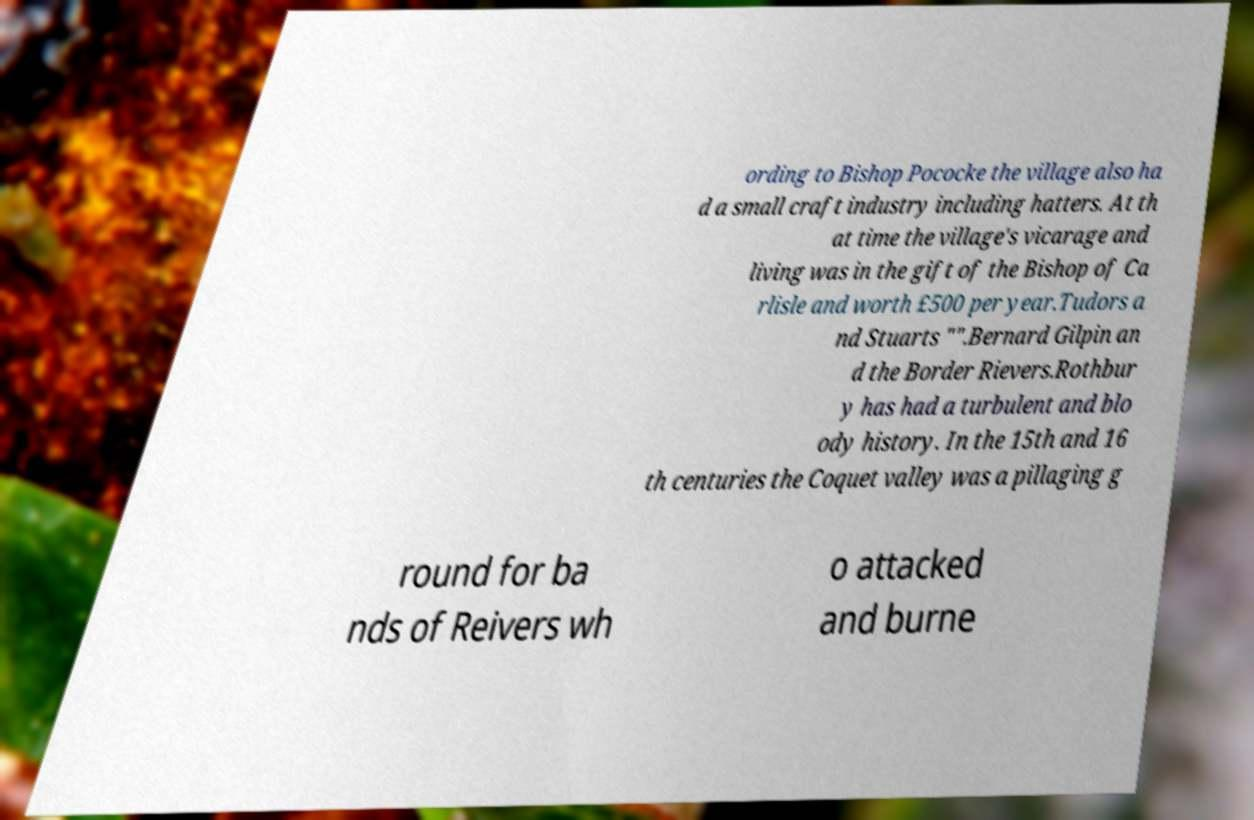Could you extract and type out the text from this image? ording to Bishop Pococke the village also ha d a small craft industry including hatters. At th at time the village's vicarage and living was in the gift of the Bishop of Ca rlisle and worth £500 per year.Tudors a nd Stuarts "".Bernard Gilpin an d the Border Rievers.Rothbur y has had a turbulent and blo ody history. In the 15th and 16 th centuries the Coquet valley was a pillaging g round for ba nds of Reivers wh o attacked and burne 